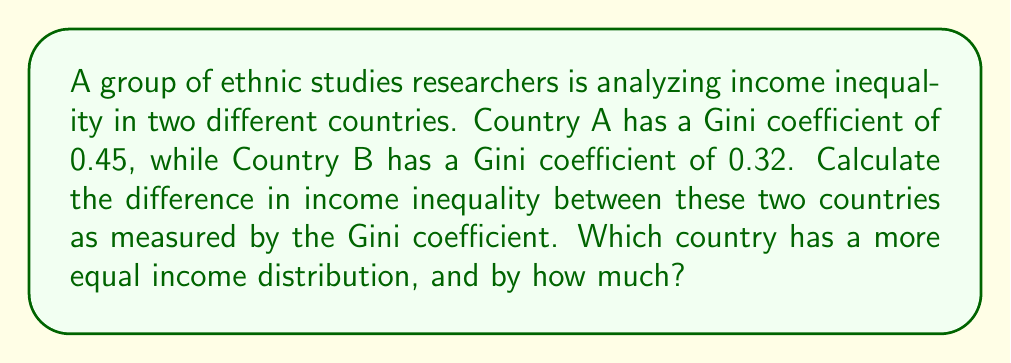Could you help me with this problem? To solve this problem, we need to understand the Gini coefficient and how to interpret it:

1. The Gini coefficient is a measure of income inequality that ranges from 0 to 1.
   - A Gini coefficient of 0 represents perfect equality (everyone has the same income).
   - A Gini coefficient of 1 represents perfect inequality (one person has all the income).

2. To compare the two countries:
   - Country A Gini coefficient: 0.45
   - Country B Gini coefficient: 0.32

3. Calculate the difference:
   $$ \text{Difference} = \text{Country A Gini} - \text{Country B Gini} $$
   $$ \text{Difference} = 0.45 - 0.32 = 0.13 $$

4. Interpret the result:
   - The positive difference (0.13) indicates that Country A has a higher Gini coefficient.
   - A higher Gini coefficient means greater income inequality.
   - Therefore, Country B has a more equal income distribution.

5. Express the difference:
   - Country B's income distribution is more equal by 0.13 Gini coefficient points.
Answer: Country B; 0.13 